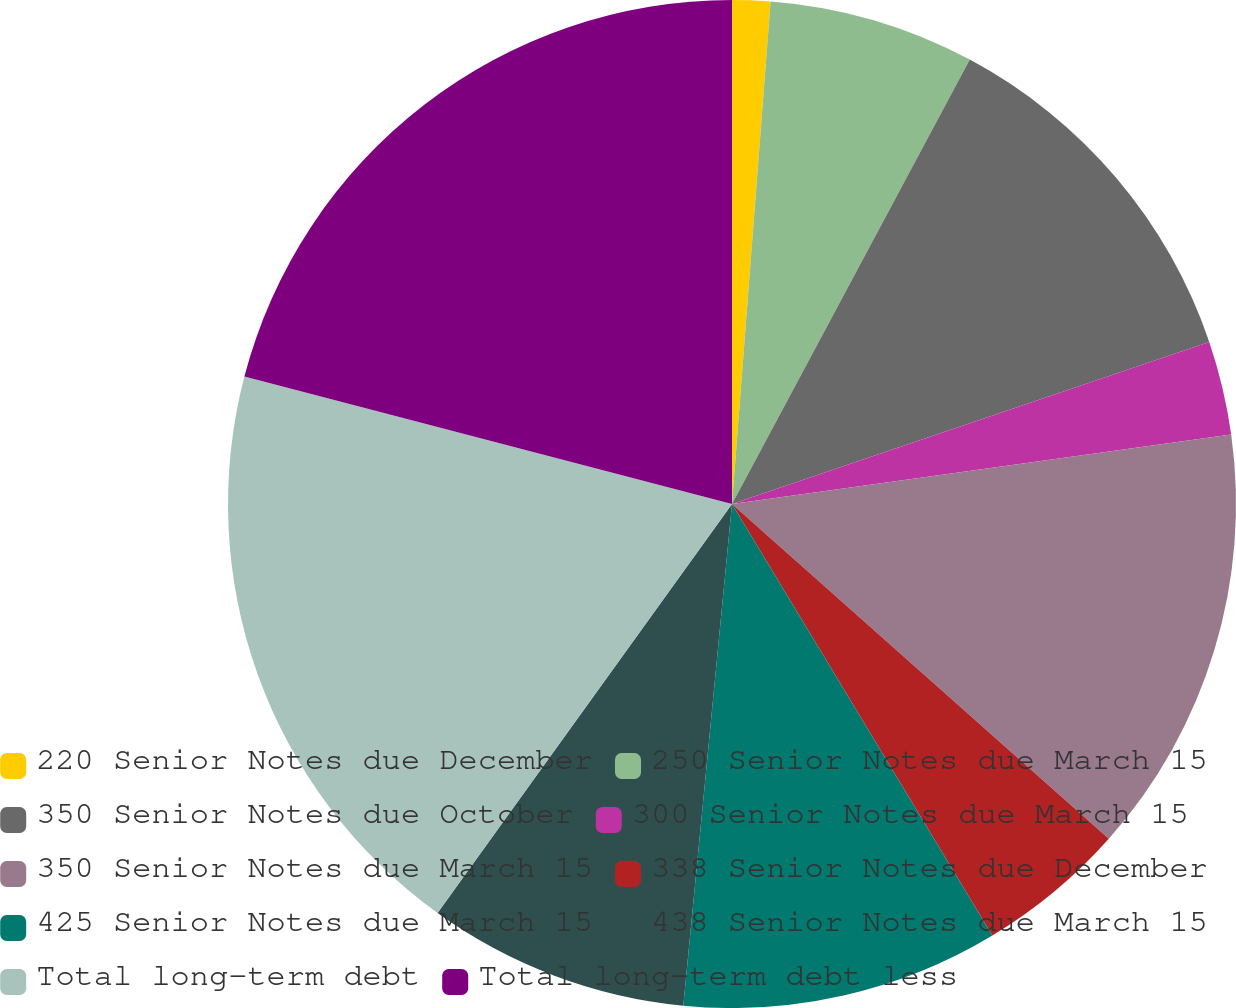<chart> <loc_0><loc_0><loc_500><loc_500><pie_chart><fcel>220 Senior Notes due December<fcel>250 Senior Notes due March 15<fcel>350 Senior Notes due October<fcel>300 Senior Notes due March 15<fcel>350 Senior Notes due March 15<fcel>338 Senior Notes due December<fcel>425 Senior Notes due March 15<fcel>438 Senior Notes due March 15<fcel>Total long-term debt<fcel>Total long-term debt less<nl><fcel>1.22%<fcel>6.6%<fcel>11.97%<fcel>3.01%<fcel>13.76%<fcel>4.8%<fcel>10.18%<fcel>8.39%<fcel>19.14%<fcel>20.93%<nl></chart> 